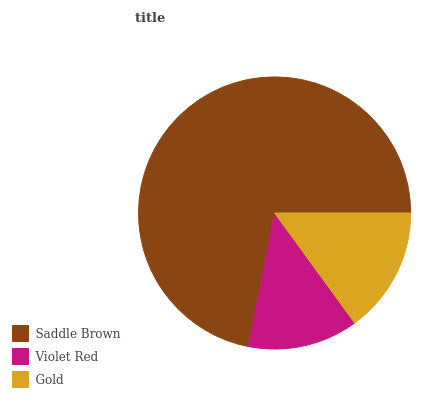Is Violet Red the minimum?
Answer yes or no. Yes. Is Saddle Brown the maximum?
Answer yes or no. Yes. Is Gold the minimum?
Answer yes or no. No. Is Gold the maximum?
Answer yes or no. No. Is Gold greater than Violet Red?
Answer yes or no. Yes. Is Violet Red less than Gold?
Answer yes or no. Yes. Is Violet Red greater than Gold?
Answer yes or no. No. Is Gold less than Violet Red?
Answer yes or no. No. Is Gold the high median?
Answer yes or no. Yes. Is Gold the low median?
Answer yes or no. Yes. Is Saddle Brown the high median?
Answer yes or no. No. Is Violet Red the low median?
Answer yes or no. No. 